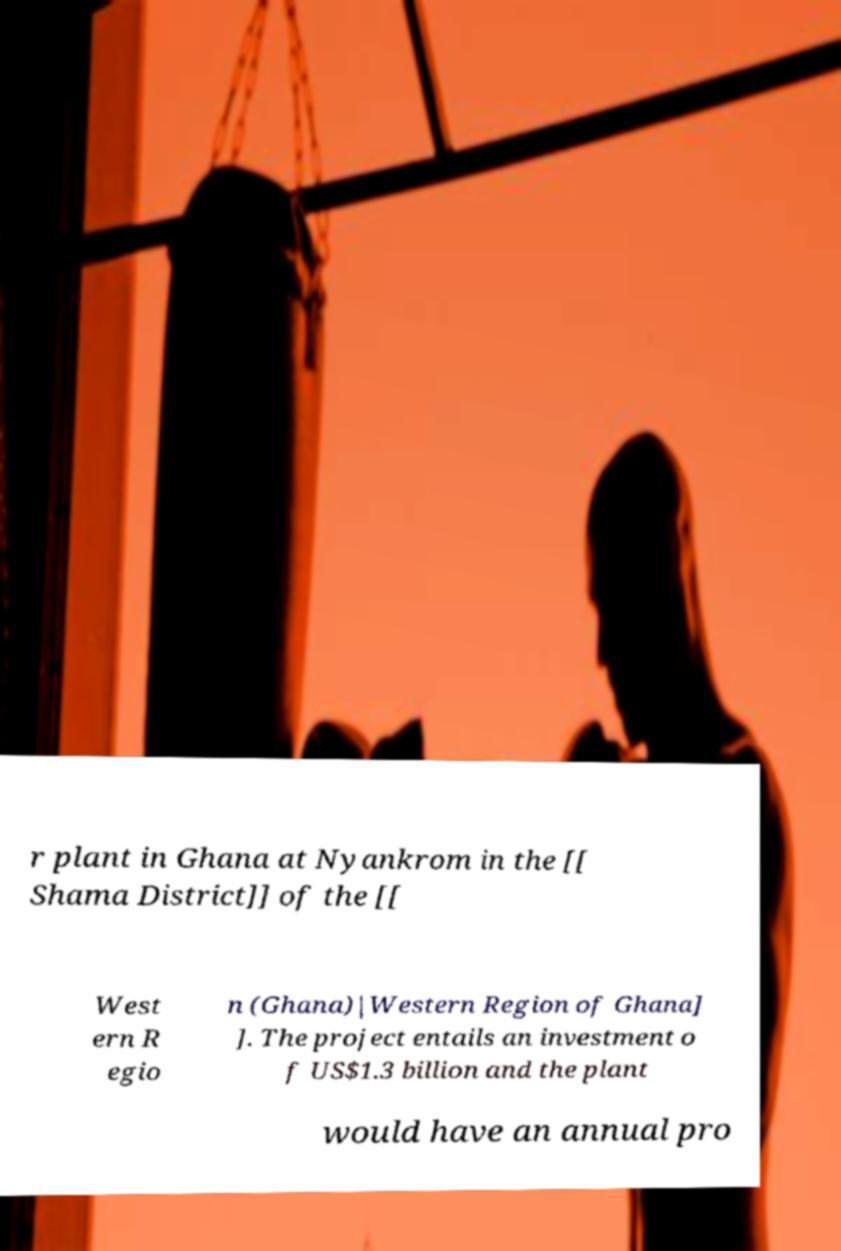For documentation purposes, I need the text within this image transcribed. Could you provide that? r plant in Ghana at Nyankrom in the [[ Shama District]] of the [[ West ern R egio n (Ghana)|Western Region of Ghana] ]. The project entails an investment o f US$1.3 billion and the plant would have an annual pro 